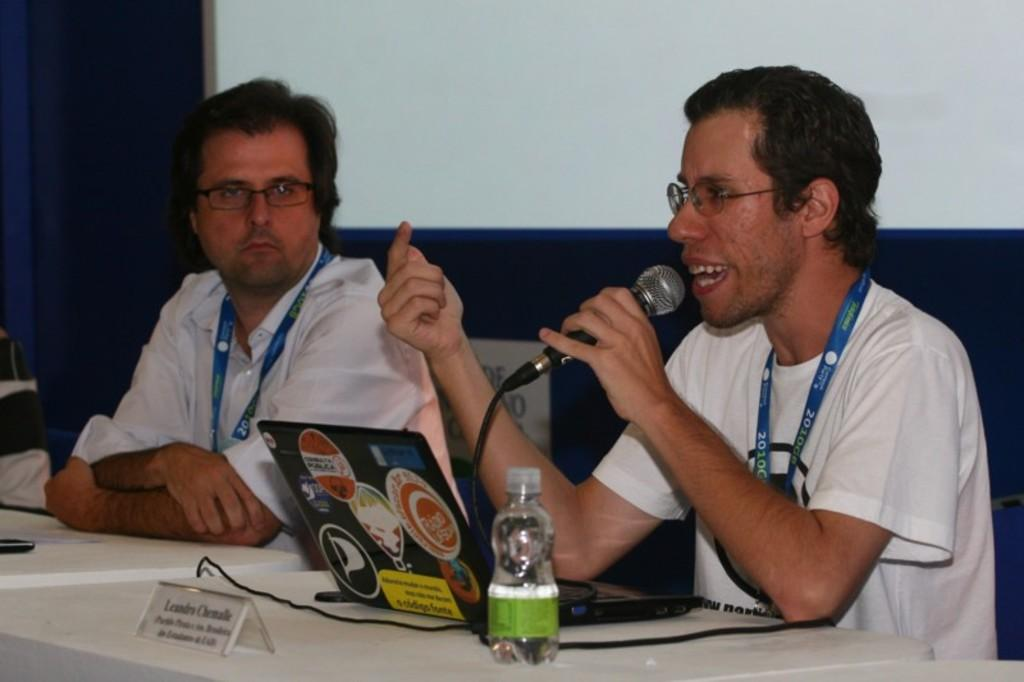What is the person holding in the image? The person is holding a mic in the image. Where is the person holding the mic sitting? The person holding the mic is sitting beside a table. What can be found on the table in the image? The table contains a laptop, a stand, a wire, and a bottle. Who else is present in the image? There is another person sitting beside the person holding the mic. What type of disgusting smell can be detected in the image? There is no mention of any smell, disgusting or otherwise, in the image. 